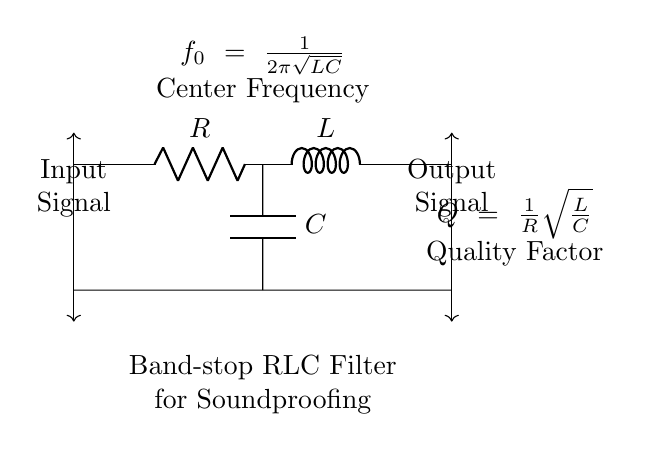What type of filter is represented in the circuit? The circuit shows a band-stop filter, which is designed to attenuate specific frequency ranges while allowing others to pass. This is indicated by the labeling in the diagram.
Answer: Band-stop filter What components are present in the circuit? The circuit contains three components: a resistor, an inductor, and a capacitor. The labels on the diagram clearly identify these components.
Answer: Resistor, Inductor, Capacitor What does the symbol located at the center of the circuit represent? The symbol at the center, labeled as \( f_0 \), represents the center frequency of the filter calculated using the formula provided in the circuit. This indicates the frequency that the filter is primarily designed to affect.
Answer: Center Frequency How is the quality factor \( Q \) defined in this circuit? The quality factor \( Q \) is defined by the formula included in the diagram, which indicates that it is a function of the resistance \( R \), inductance \( L \), and capacitance \( C \). This shows how sharply the filter can select its frequency.
Answer: \( Q = \frac{1}{R}\sqrt{\frac{L}{C}} \) What is the purpose of the inductor in this band-stop filter? The inductor serves to introduce reactance at certain frequencies, which contributes to the filter's ability to stop or attenuate specific frequencies while permitting others to pass through. Its behavior is vital in combination with the capacitor and resistor for achieving the desired attenuation characteristics.
Answer: Attenuate specific frequencies At what frequency will maximum attenuation occur? Maximum attenuation occurs at the center frequency denoted by \( f_0 \), which is given by the formula \( f_0 = \frac{1}{2\pi\sqrt{LC}} \) in the circuit. This reflects the specific frequency that the filter is intended to impact the most.
Answer: Frequency \( f_0 \) What effect does increasing the resistance \( R \) have on the quality factor \( Q \)? Increasing the resistance \( R \) decreases the quality factor \( Q \) according to the formula provided. This implies that higher resistance results in a less selective filter, affecting how sharply the filter responds to its center frequency.
Answer: Decrease \( Q \) 